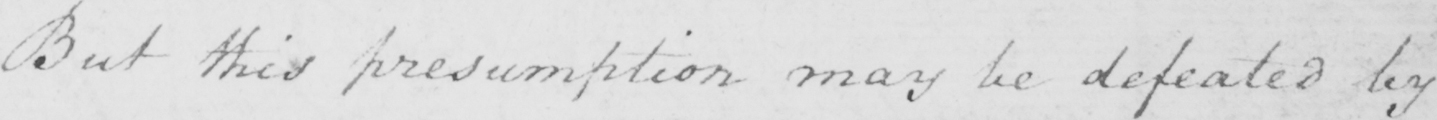Can you read and transcribe this handwriting? But this presumption may be defeated by 